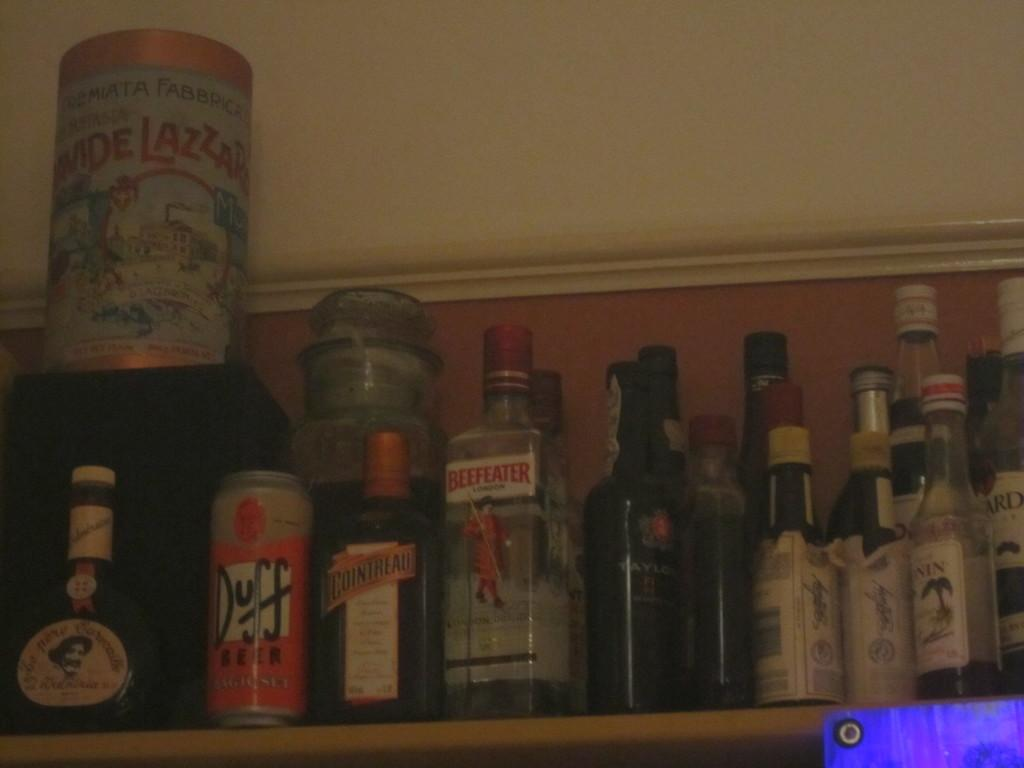<image>
Share a concise interpretation of the image provided. A shelf with liquor bottles and one that reads Beefeater. 